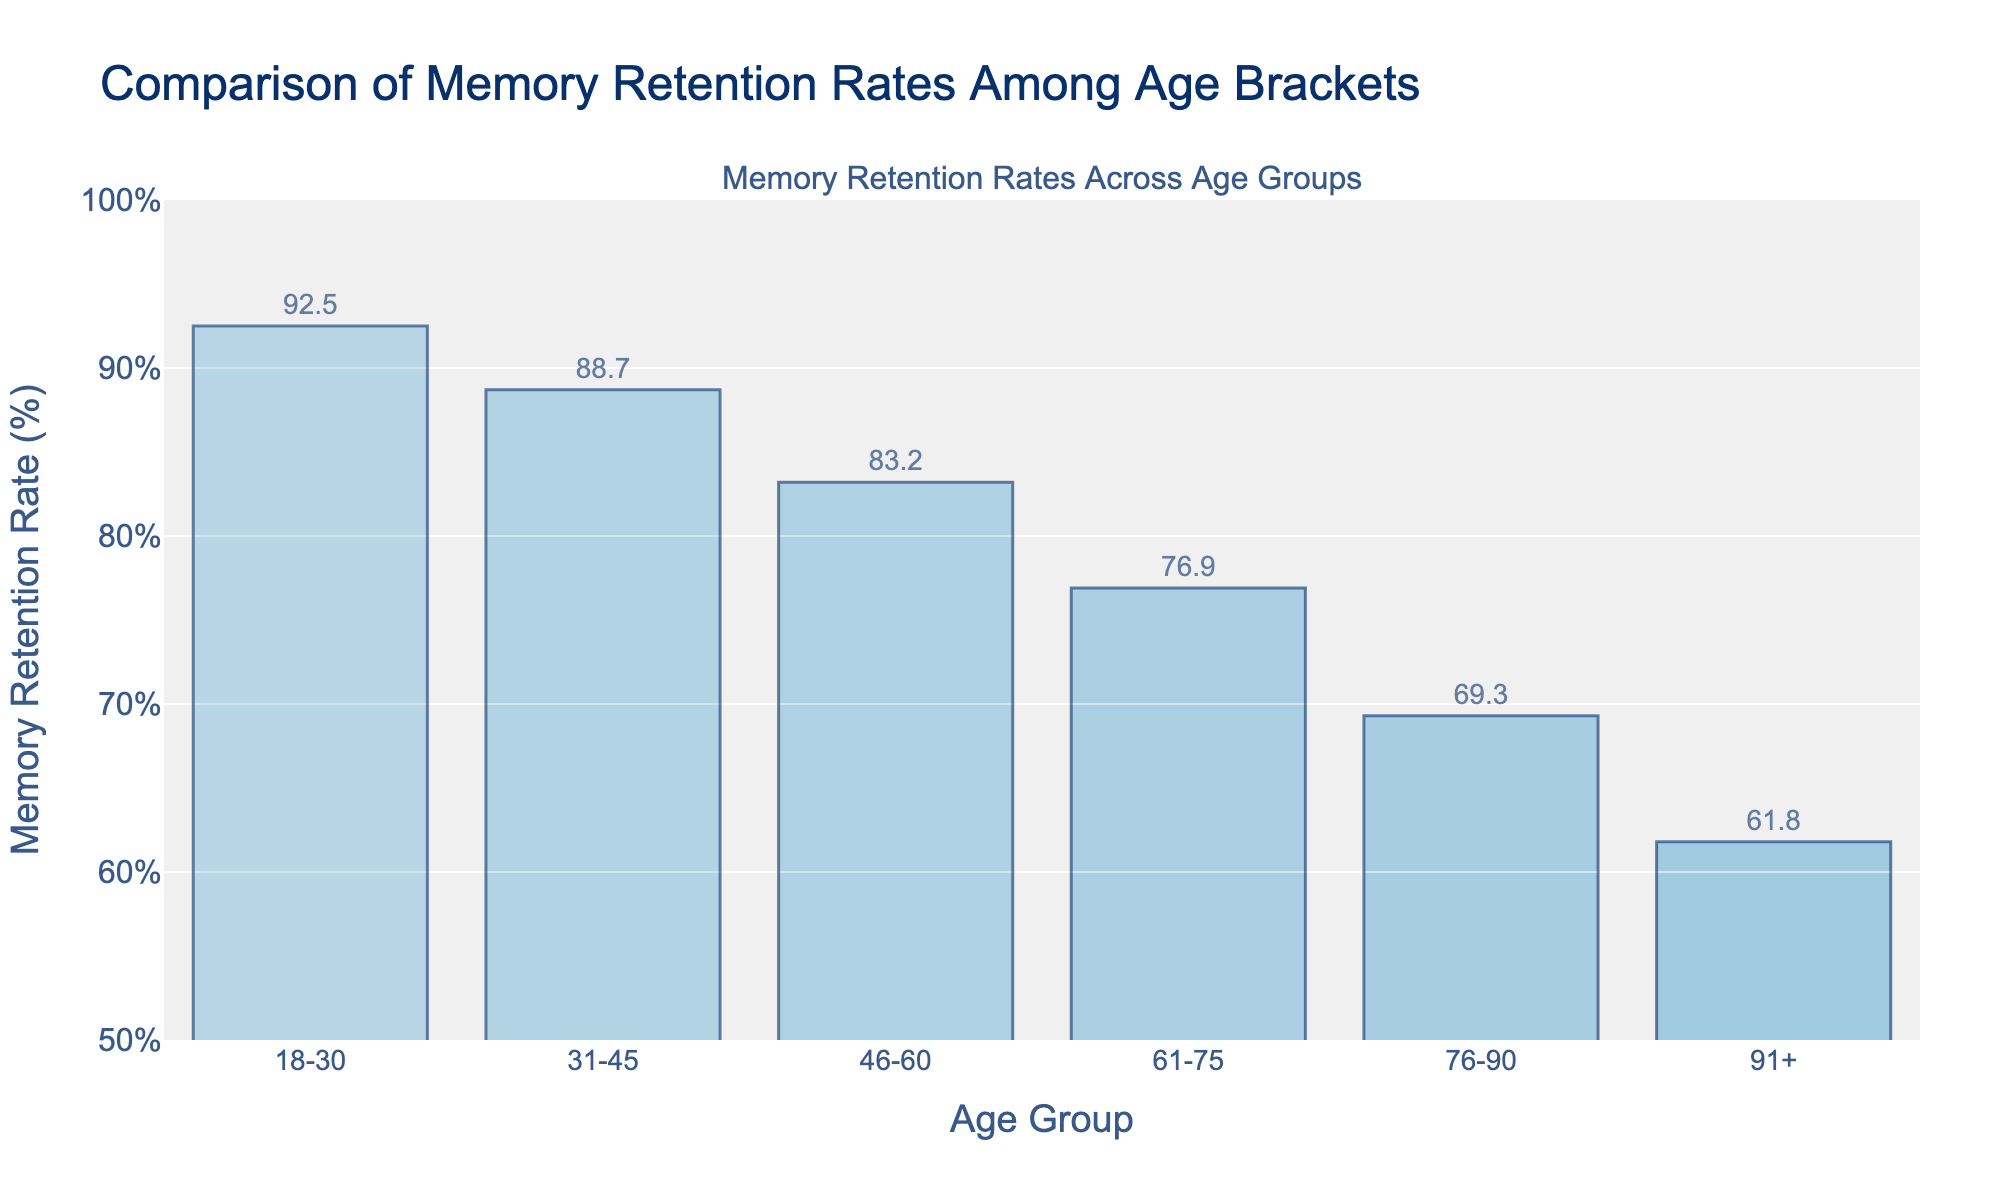What is the memory retention rate for the 61-75 age group? Look at the bar corresponding to the 61-75 age group. The number displayed on top of the bar is the memory retention rate.
Answer: 76.9% Which age group has the lowest memory retention rate? Compare the heights of all the bars and identify the smallest one. The lowest bar corresponds to the age group 91+.
Answer: 91+ How much lower is the memory retention rate for the 76-90 age group compared to the 18-30 age group? Subtract the memory retention rate of the 76-90 age group (69.3%) from the 18-30 age group (92.5%).
Answer: 23.2% What is the difference in memory retention rates between the 31-45 and 46-60 age groups? Subtract the memory retention rate of the 46-60 age group (83.2%) from the 31-45 age group (88.7%).
Answer: 5.5% Which age group has a memory retention rate of approximately 88%? Look at the bar with the value closest to 88%. The 31-45 age group has a retention rate close to this value.
Answer: 31-45 What is the average memory retention rate of all age groups? Sum all the memory retention rates (92.5 + 88.7 + 83.2 + 76.9 + 69.3 + 61.8) and divide by the number of age groups (6).
Answer: 78.7% Which two age groups have the most similar memory retention rates? Compare the rates and determine the pair with the smallest difference. The rates for the 18-30 (92.5%) and 31-45 (88.7%) age groups have the smallest difference.
Answer: 18-30 and 31-45 What is the total memory retention rate for age groups below 60 years? Add the retention rates for the 18-30, 31-45, and 46-60 age groups (92.5 + 88.7 + 83.2).
Answer: 264.4% How does the memory retention rate change as the age group increases from 18-30 to 91+? Observe the trend in the bar heights from the left side to the right side of the chart. The bars generally decrease in height, indicating a decline in memory retention rate with increasing age.
Answer: Decreases 